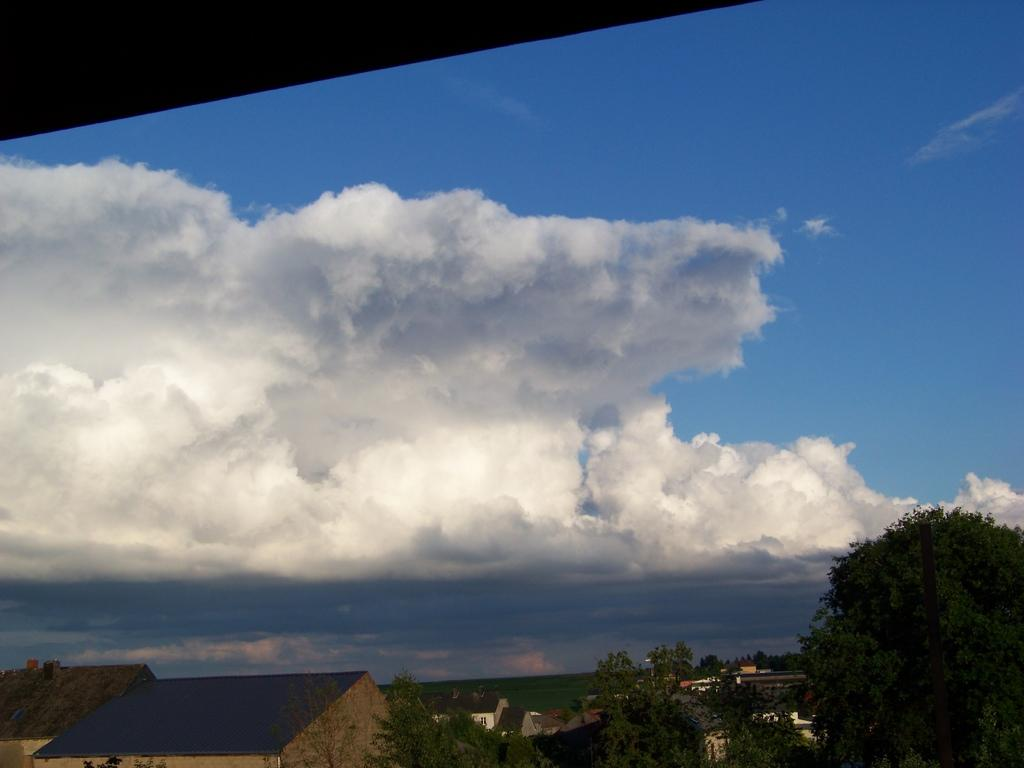What type of vegetation can be seen in the image? There are trees in the image. What type of structures are present in the image? There are houses in the image. What is visible in the background of the image? The sky is visible in the background of the image. What can be seen in the sky? There are clouds in the sky. Can you see a cow grazing in the image? There is no cow present in the image. What type of bun is being used as a prop in the image? There is no bun present in the image. 